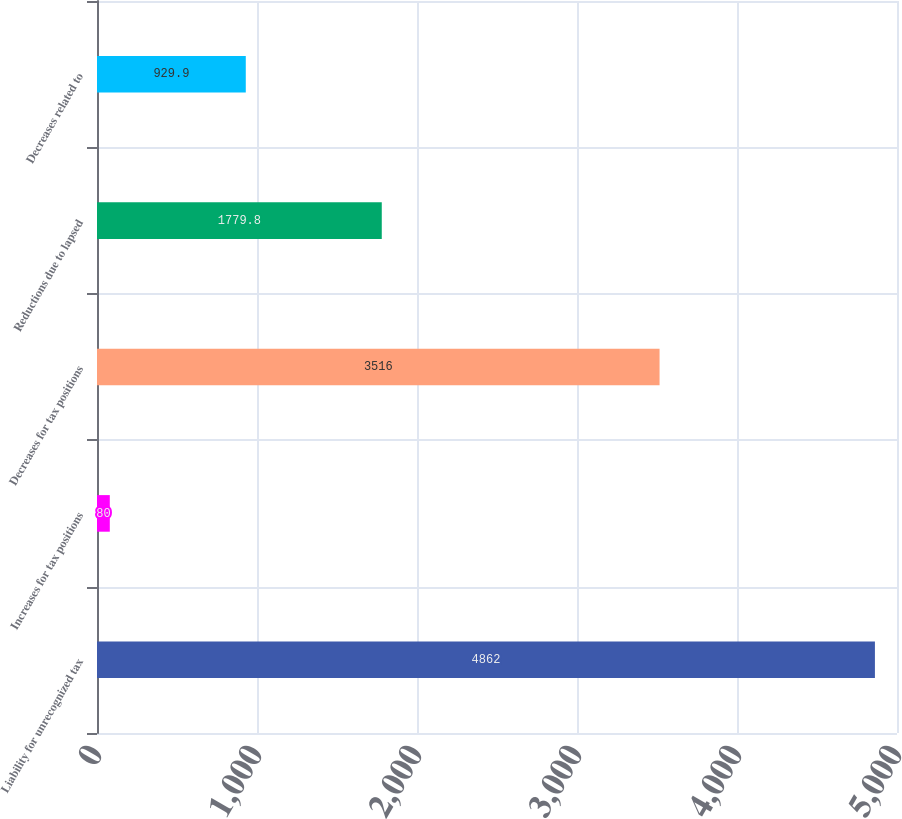Convert chart. <chart><loc_0><loc_0><loc_500><loc_500><bar_chart><fcel>Liability for unrecognized tax<fcel>Increases for tax positions<fcel>Decreases for tax positions<fcel>Reductions due to lapsed<fcel>Decreases related to<nl><fcel>4862<fcel>80<fcel>3516<fcel>1779.8<fcel>929.9<nl></chart> 